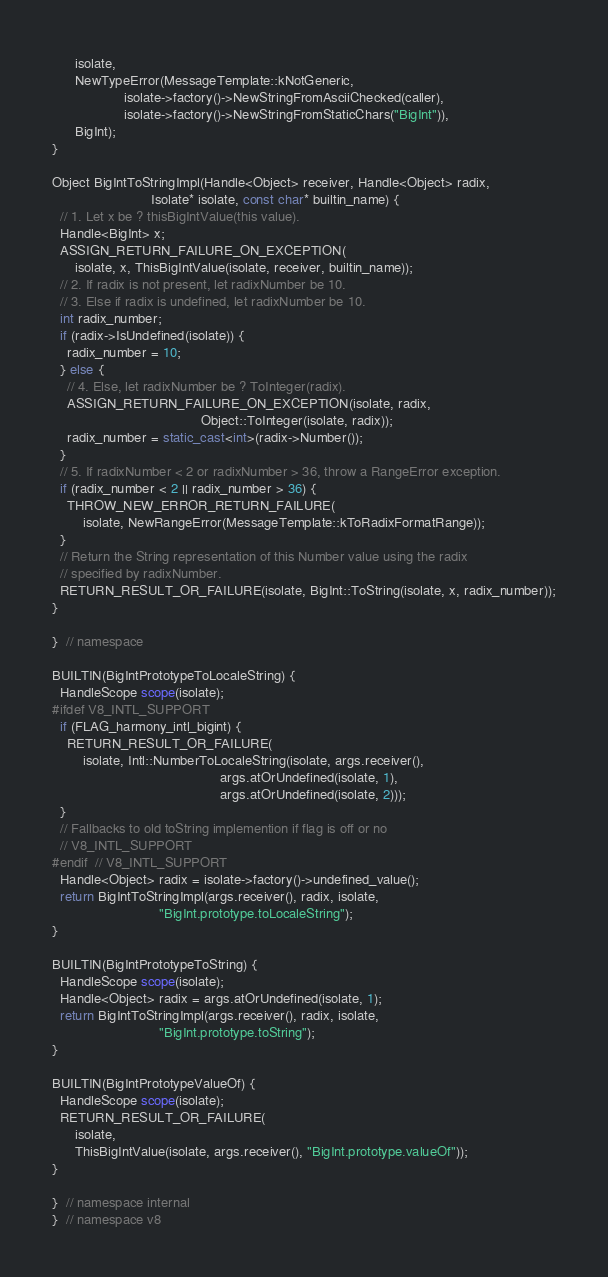<code> <loc_0><loc_0><loc_500><loc_500><_C++_>      isolate,
      NewTypeError(MessageTemplate::kNotGeneric,
                   isolate->factory()->NewStringFromAsciiChecked(caller),
                   isolate->factory()->NewStringFromStaticChars("BigInt")),
      BigInt);
}

Object BigIntToStringImpl(Handle<Object> receiver, Handle<Object> radix,
                          Isolate* isolate, const char* builtin_name) {
  // 1. Let x be ? thisBigIntValue(this value).
  Handle<BigInt> x;
  ASSIGN_RETURN_FAILURE_ON_EXCEPTION(
      isolate, x, ThisBigIntValue(isolate, receiver, builtin_name));
  // 2. If radix is not present, let radixNumber be 10.
  // 3. Else if radix is undefined, let radixNumber be 10.
  int radix_number;
  if (radix->IsUndefined(isolate)) {
    radix_number = 10;
  } else {
    // 4. Else, let radixNumber be ? ToInteger(radix).
    ASSIGN_RETURN_FAILURE_ON_EXCEPTION(isolate, radix,
                                       Object::ToInteger(isolate, radix));
    radix_number = static_cast<int>(radix->Number());
  }
  // 5. If radixNumber < 2 or radixNumber > 36, throw a RangeError exception.
  if (radix_number < 2 || radix_number > 36) {
    THROW_NEW_ERROR_RETURN_FAILURE(
        isolate, NewRangeError(MessageTemplate::kToRadixFormatRange));
  }
  // Return the String representation of this Number value using the radix
  // specified by radixNumber.
  RETURN_RESULT_OR_FAILURE(isolate, BigInt::ToString(isolate, x, radix_number));
}

}  // namespace

BUILTIN(BigIntPrototypeToLocaleString) {
  HandleScope scope(isolate);
#ifdef V8_INTL_SUPPORT
  if (FLAG_harmony_intl_bigint) {
    RETURN_RESULT_OR_FAILURE(
        isolate, Intl::NumberToLocaleString(isolate, args.receiver(),
                                            args.atOrUndefined(isolate, 1),
                                            args.atOrUndefined(isolate, 2)));
  }
  // Fallbacks to old toString implemention if flag is off or no
  // V8_INTL_SUPPORT
#endif  // V8_INTL_SUPPORT
  Handle<Object> radix = isolate->factory()->undefined_value();
  return BigIntToStringImpl(args.receiver(), radix, isolate,
                            "BigInt.prototype.toLocaleString");
}

BUILTIN(BigIntPrototypeToString) {
  HandleScope scope(isolate);
  Handle<Object> radix = args.atOrUndefined(isolate, 1);
  return BigIntToStringImpl(args.receiver(), radix, isolate,
                            "BigInt.prototype.toString");
}

BUILTIN(BigIntPrototypeValueOf) {
  HandleScope scope(isolate);
  RETURN_RESULT_OR_FAILURE(
      isolate,
      ThisBigIntValue(isolate, args.receiver(), "BigInt.prototype.valueOf"));
}

}  // namespace internal
}  // namespace v8
</code> 